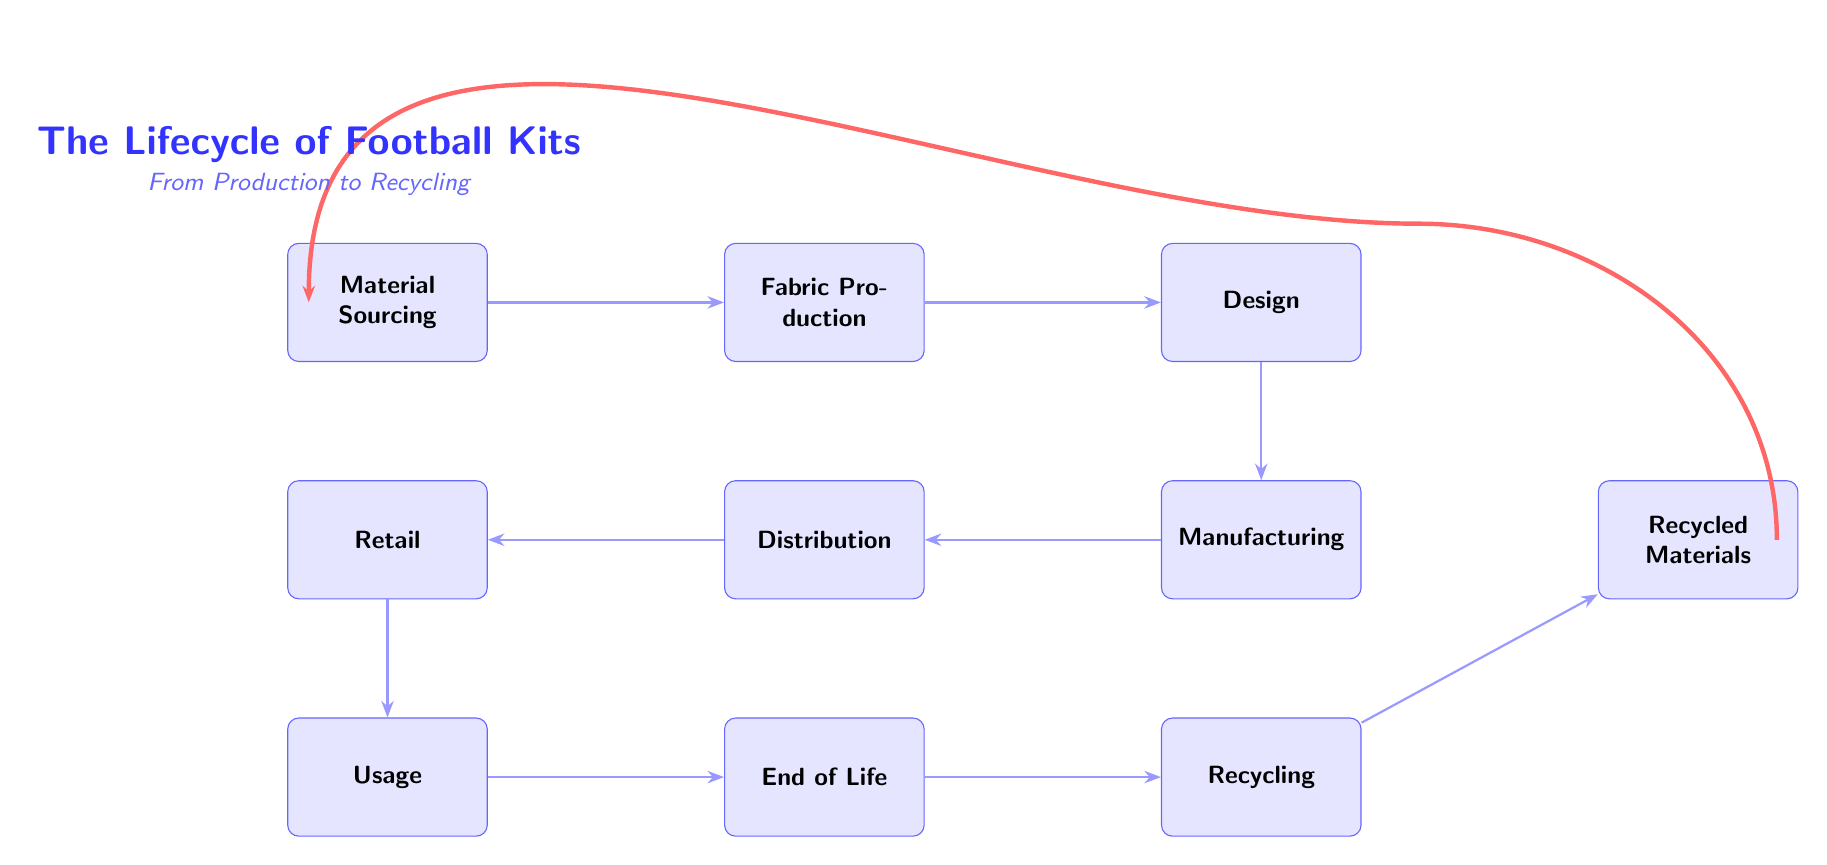What is the first stage in the lifecycle of football kits? The diagram indicates that the first stage is "Material Sourcing," as it is the leftmost node in the progression of the lifecycle.
Answer: Material Sourcing How many nodes are there in the diagram? By counting every labeled rectangle in the diagram, we find there are a total of ten distinct nodes representing different stages of the football kit lifecycle.
Answer: 10 What is the last stage before recycling? According to the flow of the diagram, the last stage before recycling is "End of Life," which immediately precedes the "Recycling" stage.
Answer: End of Life Which two stages come before manufacturing? The stages that come before "Manufacturing" are "Design" and "Fabric Production." They lead sequentially to "Manufacturing" from left to right.
Answer: Design, Fabric Production If recycling produces recycled materials, what step follows "Recycling"? The diagram shows that after the "Recycling" stage, the process leads to "Recycled Materials," indicating that these materials are the outcome of the recycling process.
Answer: Recycled Materials What is the relationship between usage and end of life? The relationship shown in the diagram indicates that "Usage" directly leads to "End of Life," suggesting that after a kit is used, it reaches its end of life stage.
Answer: Directly leads How many arrows connect the stages of production up to usage? By examining the diagram, we see there are six arrows connecting the stages from "Material Sourcing" through to "Usage," indicating the flow of the process up to this point.
Answer: 6 What stage follows distribution? The diagram clearly shows that after "Distribution," the next stage is "Retail," as indicated by the arrowflow direction in the diagram.
Answer: Retail Which stage is directly below design? The next stage directly below "Design" is "Manufacturing," as reflected by the vertical arrangement of the nodes in the diagram.
Answer: Manufacturing 